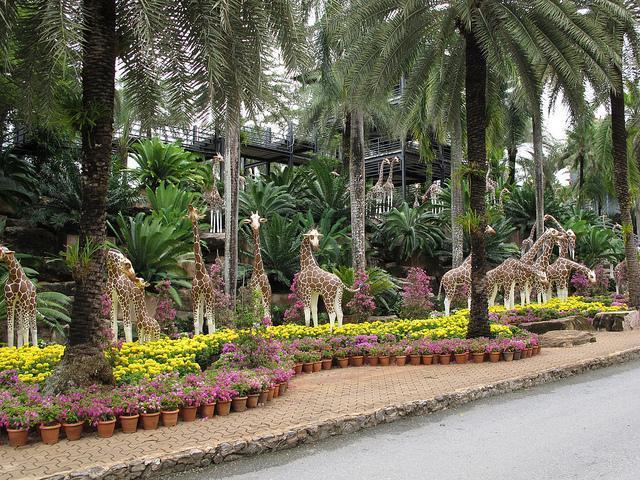How many giraffes can be seen?
Give a very brief answer. 3. 